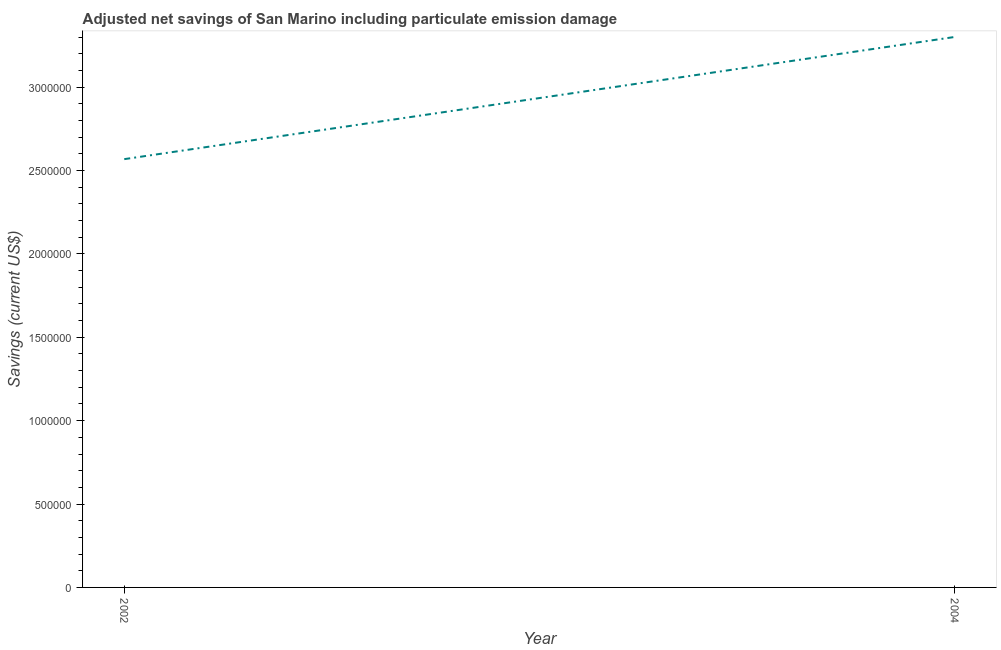What is the adjusted net savings in 2004?
Your answer should be compact. 3.30e+06. Across all years, what is the maximum adjusted net savings?
Make the answer very short. 3.30e+06. Across all years, what is the minimum adjusted net savings?
Give a very brief answer. 2.57e+06. What is the sum of the adjusted net savings?
Ensure brevity in your answer.  5.87e+06. What is the difference between the adjusted net savings in 2002 and 2004?
Keep it short and to the point. -7.33e+05. What is the average adjusted net savings per year?
Give a very brief answer. 2.93e+06. What is the median adjusted net savings?
Offer a very short reply. 2.93e+06. In how many years, is the adjusted net savings greater than 1000000 US$?
Make the answer very short. 2. Do a majority of the years between 2004 and 2002 (inclusive) have adjusted net savings greater than 400000 US$?
Provide a short and direct response. No. What is the ratio of the adjusted net savings in 2002 to that in 2004?
Keep it short and to the point. 0.78. How many lines are there?
Keep it short and to the point. 1. How many years are there in the graph?
Your answer should be compact. 2. What is the title of the graph?
Offer a very short reply. Adjusted net savings of San Marino including particulate emission damage. What is the label or title of the X-axis?
Your answer should be very brief. Year. What is the label or title of the Y-axis?
Your answer should be compact. Savings (current US$). What is the Savings (current US$) in 2002?
Provide a short and direct response. 2.57e+06. What is the Savings (current US$) in 2004?
Keep it short and to the point. 3.30e+06. What is the difference between the Savings (current US$) in 2002 and 2004?
Provide a short and direct response. -7.33e+05. What is the ratio of the Savings (current US$) in 2002 to that in 2004?
Your answer should be very brief. 0.78. 